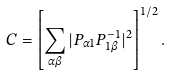<formula> <loc_0><loc_0><loc_500><loc_500>C = \left [ \sum _ { \alpha \beta } | P _ { \alpha 1 } P _ { 1 \beta } ^ { - 1 } | ^ { 2 } \right ] ^ { 1 / 2 } .</formula> 